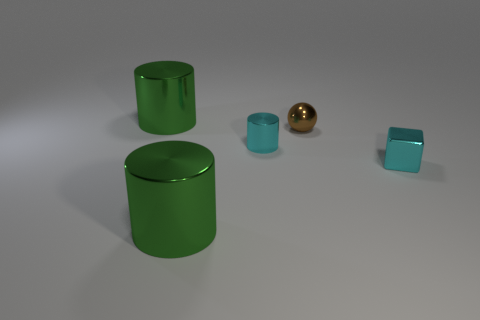Is there a shiny thing of the same color as the tiny shiny block?
Your answer should be very brief. Yes. There is a metallic cube that is the same color as the tiny cylinder; what is its size?
Provide a succinct answer. Small. Is the number of tiny things that are in front of the tiny brown ball greater than the number of cylinders?
Give a very brief answer. No. There is a object that is both right of the tiny cylinder and in front of the brown shiny sphere; what shape is it?
Offer a terse response. Cube. Do the brown metal thing and the cyan metal block have the same size?
Make the answer very short. Yes. There is a cyan metallic cylinder; how many objects are to the right of it?
Ensure brevity in your answer.  2. Is the number of tiny metallic spheres in front of the tiny cylinder the same as the number of cyan metallic cubes on the left side of the brown ball?
Keep it short and to the point. Yes. Does the brown metallic sphere have the same size as the cyan thing in front of the cyan metallic cylinder?
Make the answer very short. Yes. What number of other things are the same color as the shiny block?
Provide a succinct answer. 1. There is a tiny cyan shiny cylinder; are there any tiny brown things to the right of it?
Your answer should be compact. Yes. 